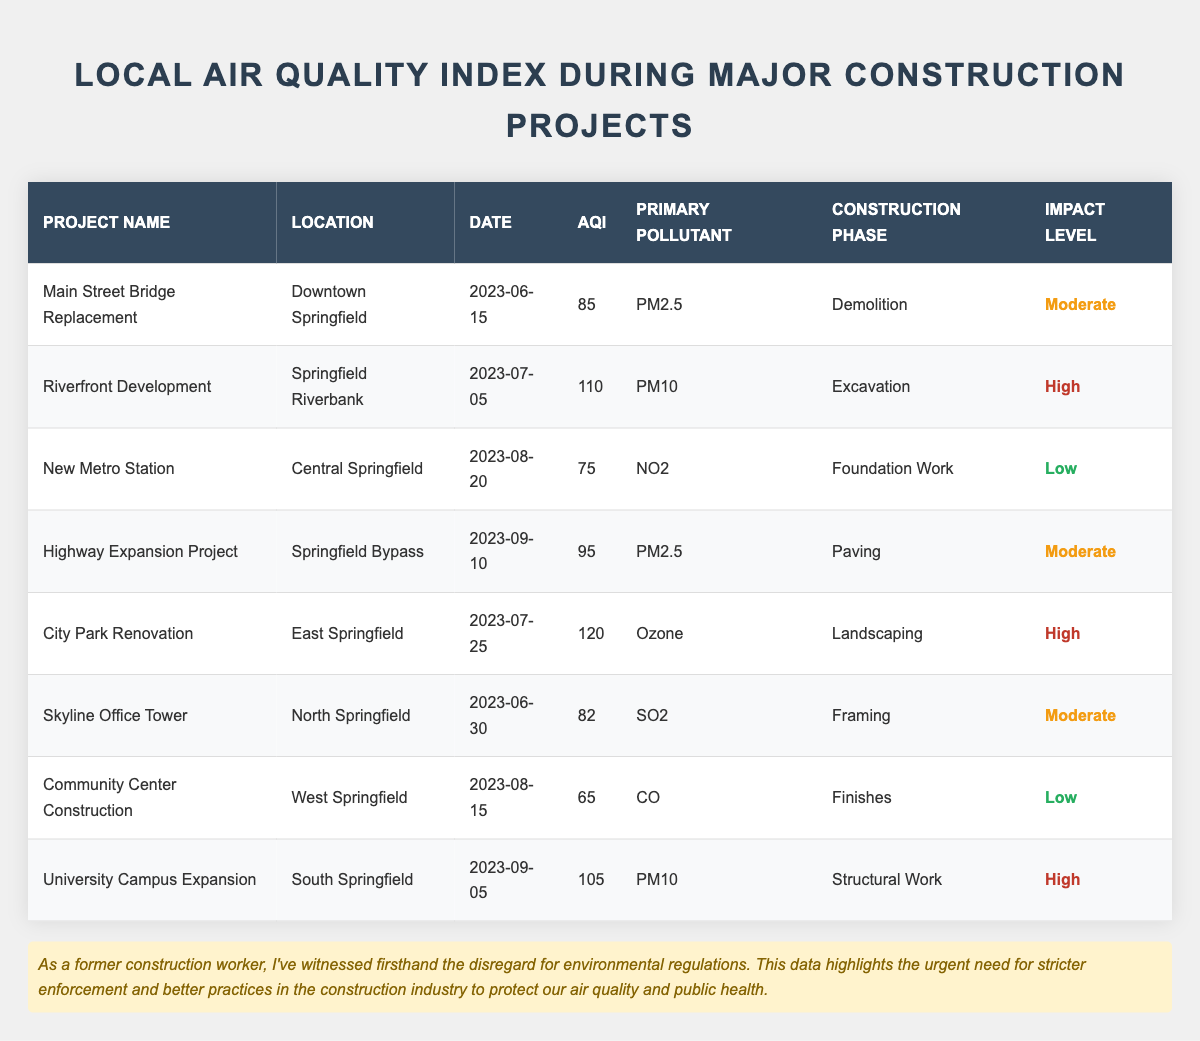What is the highest AQI recorded during these construction projects? The AQI values are: 85, 110, 75, 95, 120, 82, 65, and 105. The highest value among these is 120.
Answer: 120 Which project had the lowest air quality impact level? Looking at the impact levels, "Low" appears for the New Metro Station and Community Center Construction. Among these, the Community Center Construction has the lowest AQI of 65, confirming its "Low" impact.
Answer: Community Center Construction How many projects had a high impact level? The projects with a high impact level are Riverfront Development, City Park Renovation, and University Campus Expansion. Therefore, there are three projects with a high impact level.
Answer: 3 What was the primary pollutant during the Highway Expansion Project? The primary pollutant stated for the Highway Expansion Project is PM2.5, as mentioned in the respective row of the table.
Answer: PM2.5 What is the average AQI of projects with a moderate impact level? The AQIs for moderate impact projects are 85, 95, and 82. Adding these gives (85 + 95 + 82 = 262), and there are 3 projects, so the average AQI is 262 / 3 = 87.33, rounded to 87.
Answer: 87 Is there any construction phase that consistently had a high AQI? Examining the AQIs by construction phase, the Excavation (110) and Landscaping (120) phases had high AQIs but no construction phase consistently had a high AQI, as others showed lower values.
Answer: No Which project had the most recent date and what was its AQI? The most recent date is September 10, 2023, correlating with the Highway Expansion Project, which has an AQI of 95.
Answer: 95 Was there a project with an AQI lower than 70? The Community Center Construction had an AQI of 65, which confirms there was a project with an AQI lower than 70.
Answer: Yes How does the AQI of the New Metro Station compare to the City Park Renovation? The New Metro Station has an AQI of 75, while City Park Renovation has an AQI of 120. Therefore, the AQI of the New Metro Station is significantly lower than that of the City Park Renovation.
Answer: Lower Which location experienced the highest air pollution during construction? The City Park Renovation in East Springfield reported an AQI of 120, the highest of all projects, indicating this location experienced the most air pollution.
Answer: East Springfield 